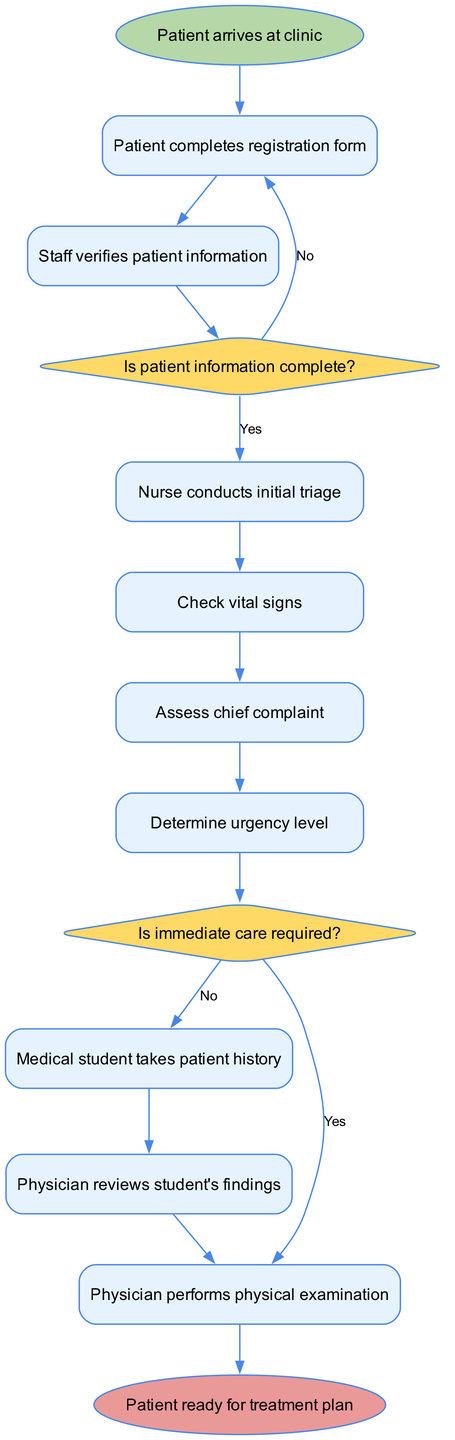What is the starting node of the diagram? The starting node, which marks the initial point in the process, is explicitly labeled in the diagram as "Patient arrives at clinic".
Answer: Patient arrives at clinic How many activities are present in the diagram? Counting each entry listed under the activities section of the diagram shows there are a total of eight activities.
Answer: 8 What decision node follows the verification of patient information? After "Staff verifies patient information", the next step leads to the decision node labeled "Is patient information complete?".
Answer: Is patient information complete? What happens if the patient information is incomplete? Referring to the decision node for patient information completeness, if the answer is "No", the process returns to re-initiate the registration.
Answer: Return to registration What is the final node in the diagram? The diagram's final terminus, indicating the conclusion of the intake process, is labeled as "Patient ready for treatment plan".
Answer: Patient ready for treatment plan What activity occurs immediately after taking patient history? After the activity "Medical student takes patient history", the subsequent activity is "Physician reviews student's findings" as per the flow of the diagram.
Answer: Physician reviews student's findings If immediate care is required, what is the next action? When the decision node for immediate care indicates "Yes", the next action taken is to "Prioritize for urgent care".
Answer: Prioritize for urgent care How many edges connect the start node to the activities? The start node connects directly to just one activity, which is "Patient completes registration form", resulting in a single edge from the starting point to the first activity.
Answer: 1 What signifies the urgency level of a patient? The urgency level of a patient is determined during the step labeled "Determine urgency level", which follows the assessment of their vital signs and chief complaint.
Answer: Determine urgency level 